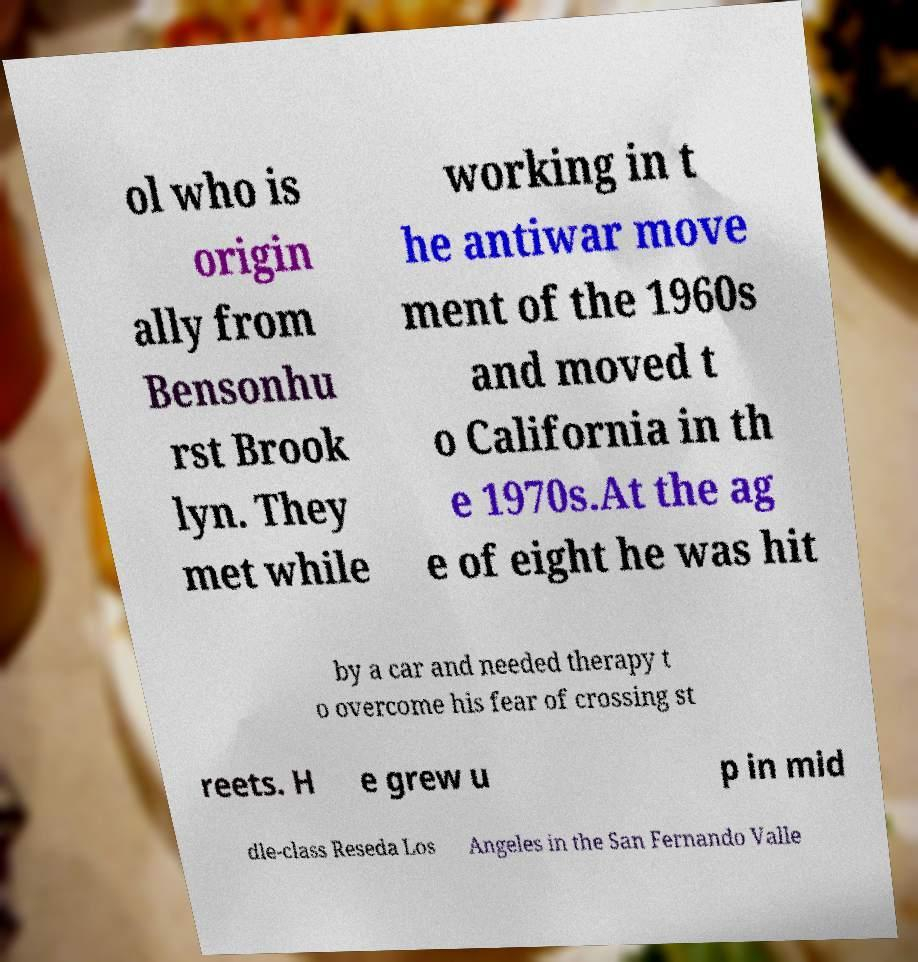Please identify and transcribe the text found in this image. ol who is origin ally from Bensonhu rst Brook lyn. They met while working in t he antiwar move ment of the 1960s and moved t o California in th e 1970s.At the ag e of eight he was hit by a car and needed therapy t o overcome his fear of crossing st reets. H e grew u p in mid dle-class Reseda Los Angeles in the San Fernando Valle 